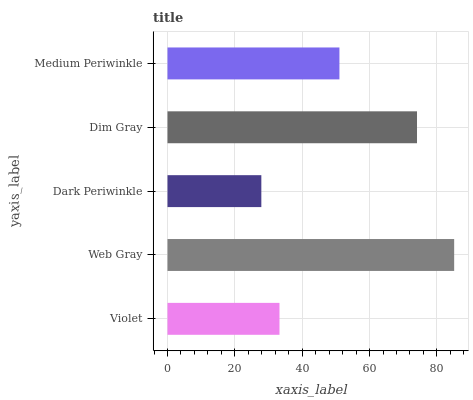Is Dark Periwinkle the minimum?
Answer yes or no. Yes. Is Web Gray the maximum?
Answer yes or no. Yes. Is Web Gray the minimum?
Answer yes or no. No. Is Dark Periwinkle the maximum?
Answer yes or no. No. Is Web Gray greater than Dark Periwinkle?
Answer yes or no. Yes. Is Dark Periwinkle less than Web Gray?
Answer yes or no. Yes. Is Dark Periwinkle greater than Web Gray?
Answer yes or no. No. Is Web Gray less than Dark Periwinkle?
Answer yes or no. No. Is Medium Periwinkle the high median?
Answer yes or no. Yes. Is Medium Periwinkle the low median?
Answer yes or no. Yes. Is Dim Gray the high median?
Answer yes or no. No. Is Dark Periwinkle the low median?
Answer yes or no. No. 